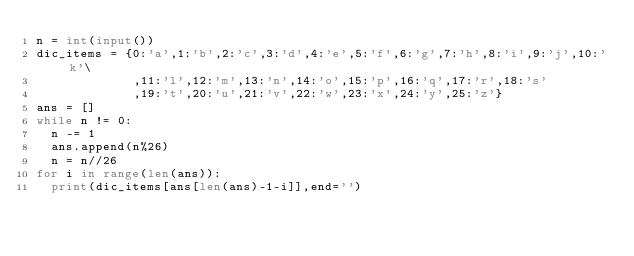<code> <loc_0><loc_0><loc_500><loc_500><_Python_>n = int(input())
dic_items = {0:'a',1:'b',2:'c',3:'d',4:'e',5:'f',6:'g',7:'h',8:'i',9:'j',10:'k'\
             ,11:'l',12:'m',13:'n',14:'o',15:'p',16:'q',17:'r',18:'s'
             ,19:'t',20:'u',21:'v',22:'w',23:'x',24:'y',25:'z'}
ans = []
while n != 0:
  n -= 1
  ans.append(n%26)
  n = n//26
for i in range(len(ans)):
  print(dic_items[ans[len(ans)-1-i]],end='')

</code> 